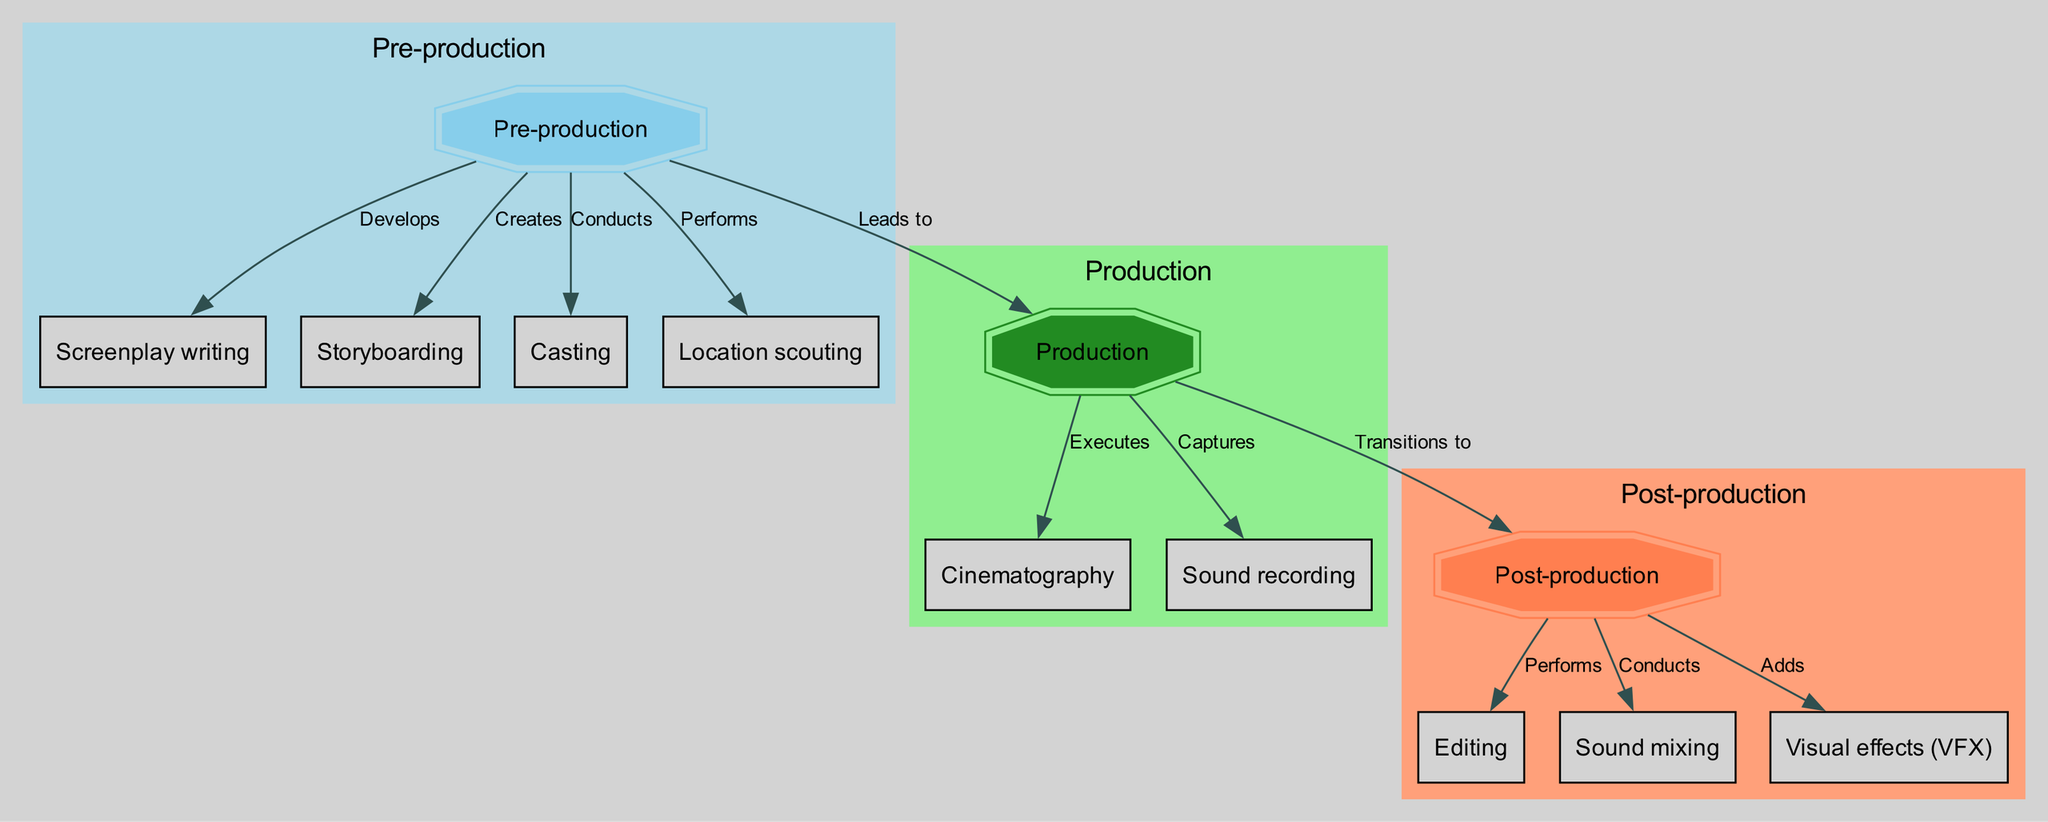What are the three main phases of film production? The diagram clearly delineates three main phases: Pre-production, Production, and Post-production, which are visually categorized in separate clusters.
Answer: Pre-production, Production, Post-production How many nodes are there in this diagram? By counting each unique labeled component (nodes) in the diagram, including Pre-production, Production, Post-production, and their corresponding activities, we find a total of 11 nodes.
Answer: 11 What activity leads to cinematography? The edge labeled "Executes" directly connects Production to Cinematography, indicating that the Production phase directly leads to this activity.
Answer: Production Which activity is performed during post-production? The diagram includes Editing, Sound mixing, and Visual effects as activities categorized under Post-production, indicating that these activities are all part of the post-production phase.
Answer: Editing, Sound mixing, Visual effects What is the relationship between pre-production and casting? The edge labeled "Conducts" connects Pre-production to Casting, illustrating that casting is a necessary step carried out during the pre-production phase.
Answer: Conducts How is sound recorded during film production? The diagram specifies that sound recording is captured within the Production phase, thus indicating its execution at this point in the film production process.
Answer: Captures Which two phases are connected with a transition? The diagram shows that the Production phase transitions to Post-production, which is explicitly labeled by the edge marked "Transitions to."
Answer: Production, Post-production How many edges are there that connect activities? Counting the lines (or edges) that illustrate the relationships and processes between nodes gives a total of 9 edges in this diagram.
Answer: 9 What processes occur in the post-production phase? The diagram states that during Post-production, editing, sound mixing, and adding visual effects are the primary processes performed, reflecting the tasks carried out after filming is complete.
Answer: Editing, Sound mixing, Visual effects 